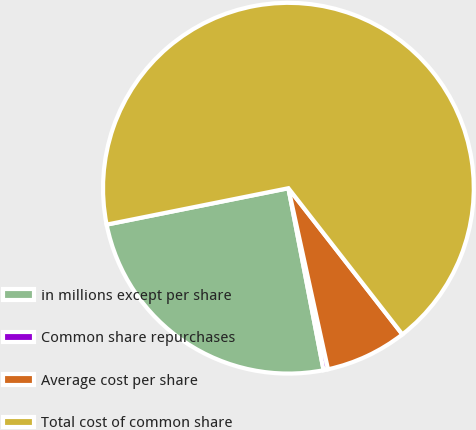Convert chart. <chart><loc_0><loc_0><loc_500><loc_500><pie_chart><fcel>in millions except per share<fcel>Common share repurchases<fcel>Average cost per share<fcel>Total cost of common share<nl><fcel>24.89%<fcel>0.39%<fcel>7.11%<fcel>67.6%<nl></chart> 